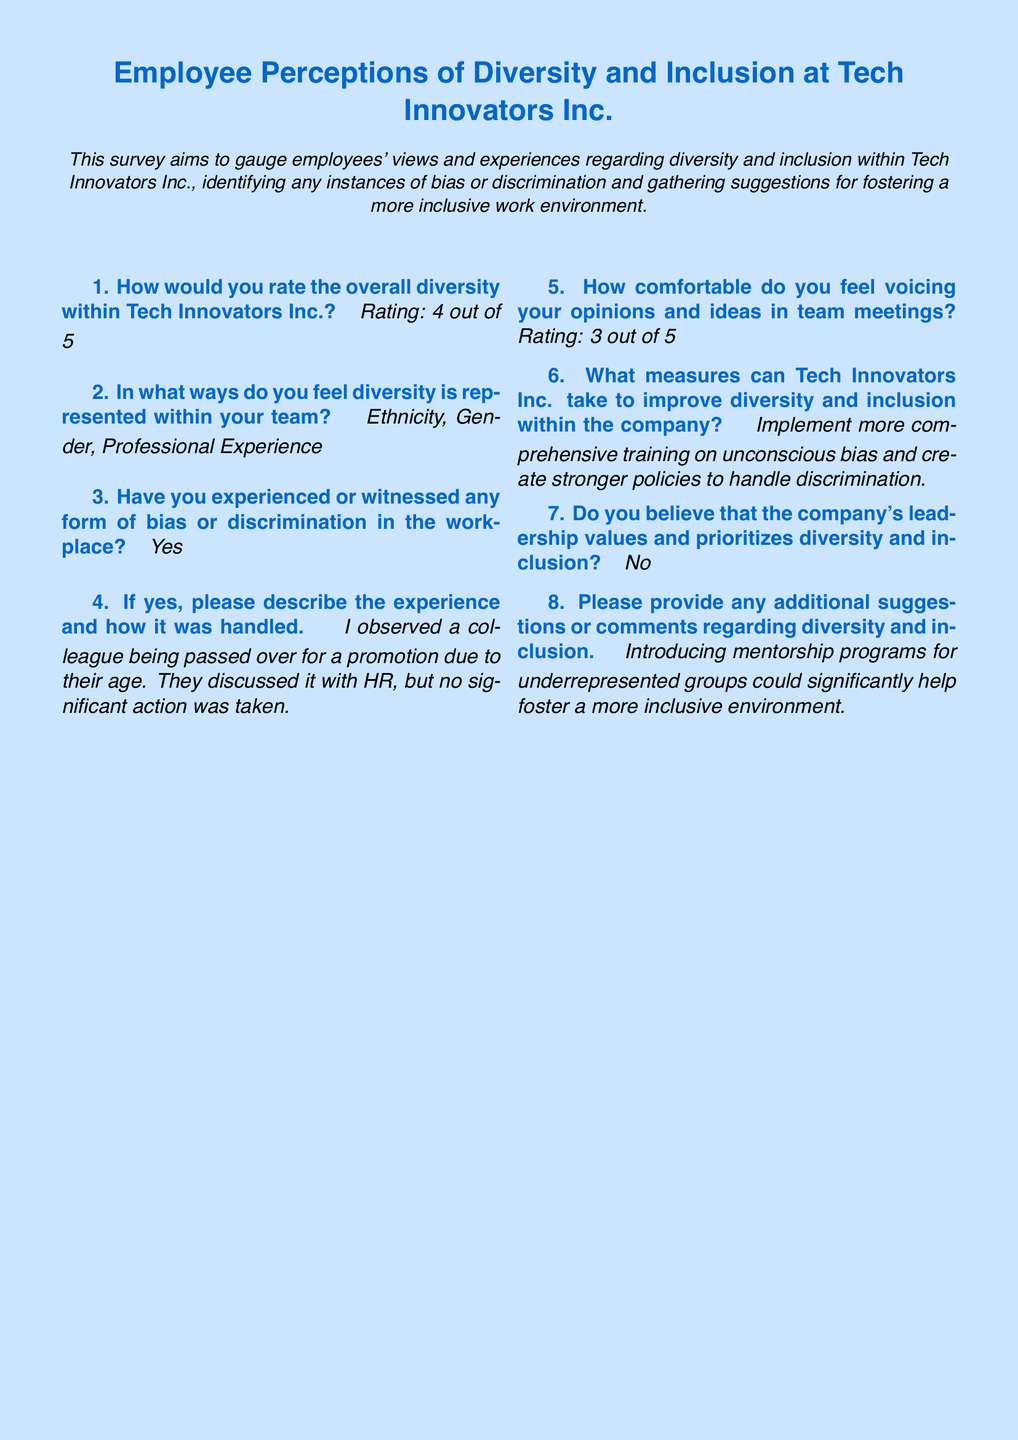What is the overall diversity rating at Tech Innovators Inc.? The overall diversity rating is specified clearly in the survey response.
Answer: 4 out of 5 What areas of diversity are represented within the team? The answer includes specific aspects of diversity that the respondent perceives in their team.
Answer: Ethnicity, Gender, Professional Experience How comfortable do employees feel voicing their opinions in meetings? The comfort level is provided as a rating, which reflects the employee's experience.
Answer: 3 out of 5 What measures are suggested to improve diversity and inclusion? This response requires understanding of the recommendations made by the employee for improvement.
Answer: Implement more comprehensive training on unconscious bias and create stronger policies to handle discrimination Did the employee believe that the company's leadership prioritizes diversity? The answer reflects the employee's perception of leadership's commitment to diversity and inclusion.
Answer: No What specific incident of bias was reported by the employee? The answer provides insight into a particular instance experienced in the workplace and references how it was addressed.
Answer: A colleague being passed over for a promotion due to their age What additional suggestion was made for fostering an inclusive environment? This question combines understanding of experience and suggestions, as the answer provides insight into further improvements.
Answer: Introducing mentorship programs for underrepresented groups 